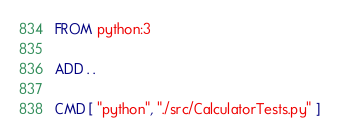Convert code to text. <code><loc_0><loc_0><loc_500><loc_500><_Dockerfile_>FROM python:3

ADD . .

CMD [ "python", "./src/CalculatorTests.py" ]</code> 